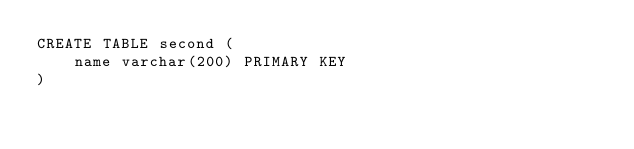Convert code to text. <code><loc_0><loc_0><loc_500><loc_500><_SQL_>CREATE TABLE second (
	name varchar(200) PRIMARY KEY
)
</code> 